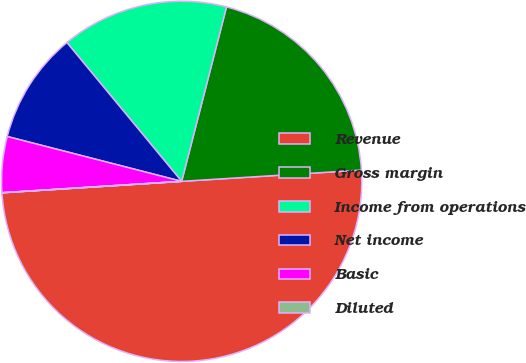<chart> <loc_0><loc_0><loc_500><loc_500><pie_chart><fcel>Revenue<fcel>Gross margin<fcel>Income from operations<fcel>Net income<fcel>Basic<fcel>Diluted<nl><fcel>49.98%<fcel>20.0%<fcel>15.0%<fcel>10.0%<fcel>5.01%<fcel>0.01%<nl></chart> 